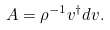Convert formula to latex. <formula><loc_0><loc_0><loc_500><loc_500>A = \rho ^ { - 1 } v ^ { \dagger } d v .</formula> 